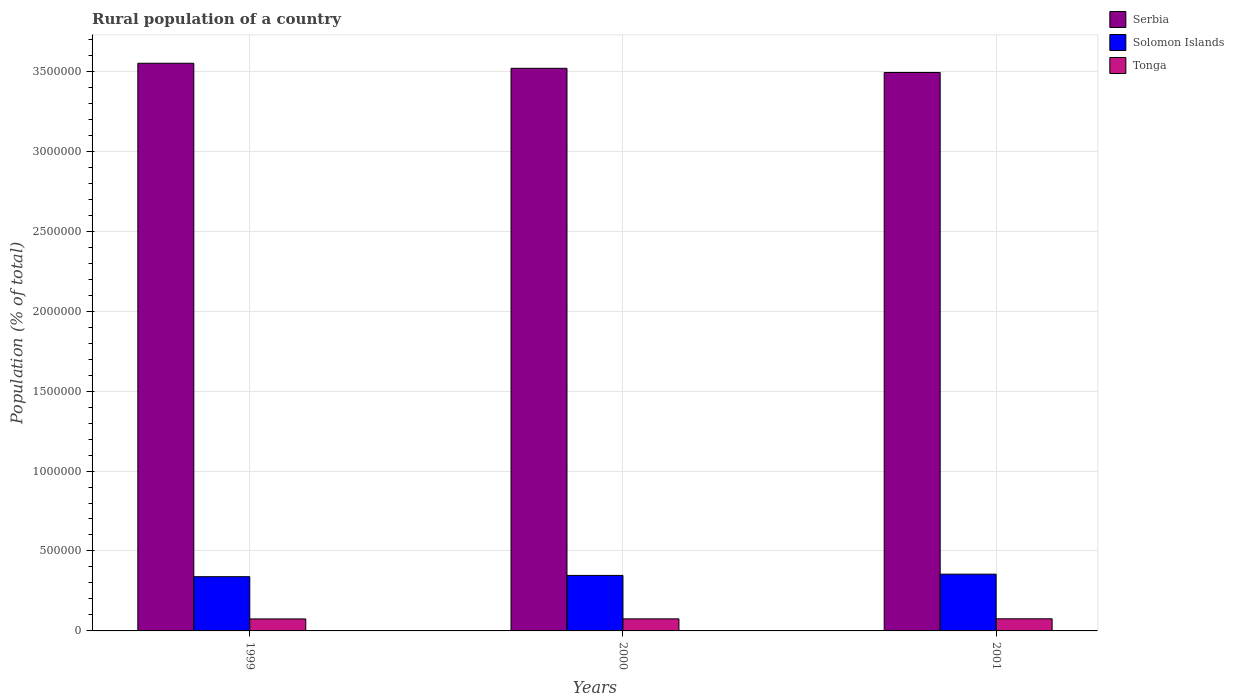How many groups of bars are there?
Your answer should be very brief. 3. Are the number of bars on each tick of the X-axis equal?
Provide a succinct answer. Yes. In how many cases, is the number of bars for a given year not equal to the number of legend labels?
Your response must be concise. 0. What is the rural population in Serbia in 2000?
Provide a succinct answer. 3.52e+06. Across all years, what is the maximum rural population in Serbia?
Your response must be concise. 3.55e+06. Across all years, what is the minimum rural population in Solomon Islands?
Provide a short and direct response. 3.39e+05. In which year was the rural population in Tonga maximum?
Your answer should be compact. 2001. In which year was the rural population in Solomon Islands minimum?
Your response must be concise. 1999. What is the total rural population in Serbia in the graph?
Offer a very short reply. 1.06e+07. What is the difference between the rural population in Serbia in 1999 and that in 2000?
Your answer should be compact. 3.15e+04. What is the difference between the rural population in Serbia in 2001 and the rural population in Solomon Islands in 1999?
Your response must be concise. 3.15e+06. What is the average rural population in Solomon Islands per year?
Your answer should be compact. 3.47e+05. In the year 2000, what is the difference between the rural population in Solomon Islands and rural population in Tonga?
Offer a terse response. 2.72e+05. In how many years, is the rural population in Tonga greater than 2200000 %?
Keep it short and to the point. 0. What is the ratio of the rural population in Serbia in 1999 to that in 2001?
Provide a succinct answer. 1.02. What is the difference between the highest and the second highest rural population in Serbia?
Offer a terse response. 3.15e+04. What is the difference between the highest and the lowest rural population in Serbia?
Your answer should be very brief. 5.77e+04. What does the 1st bar from the left in 2000 represents?
Your answer should be compact. Serbia. What does the 3rd bar from the right in 2001 represents?
Make the answer very short. Serbia. Is it the case that in every year, the sum of the rural population in Solomon Islands and rural population in Tonga is greater than the rural population in Serbia?
Offer a very short reply. No. Are all the bars in the graph horizontal?
Your answer should be compact. No. Does the graph contain any zero values?
Your response must be concise. No. Does the graph contain grids?
Give a very brief answer. Yes. How are the legend labels stacked?
Give a very brief answer. Vertical. What is the title of the graph?
Your answer should be compact. Rural population of a country. What is the label or title of the Y-axis?
Make the answer very short. Population (% of total). What is the Population (% of total) of Serbia in 1999?
Keep it short and to the point. 3.55e+06. What is the Population (% of total) of Solomon Islands in 1999?
Keep it short and to the point. 3.39e+05. What is the Population (% of total) of Tonga in 1999?
Make the answer very short. 7.50e+04. What is the Population (% of total) in Serbia in 2000?
Your response must be concise. 3.52e+06. What is the Population (% of total) in Solomon Islands in 2000?
Your answer should be very brief. 3.47e+05. What is the Population (% of total) in Tonga in 2000?
Your response must be concise. 7.54e+04. What is the Population (% of total) of Serbia in 2001?
Your answer should be compact. 3.49e+06. What is the Population (% of total) in Solomon Islands in 2001?
Ensure brevity in your answer.  3.55e+05. What is the Population (% of total) in Tonga in 2001?
Offer a very short reply. 7.58e+04. Across all years, what is the maximum Population (% of total) of Serbia?
Provide a short and direct response. 3.55e+06. Across all years, what is the maximum Population (% of total) of Solomon Islands?
Ensure brevity in your answer.  3.55e+05. Across all years, what is the maximum Population (% of total) of Tonga?
Make the answer very short. 7.58e+04. Across all years, what is the minimum Population (% of total) of Serbia?
Give a very brief answer. 3.49e+06. Across all years, what is the minimum Population (% of total) of Solomon Islands?
Your answer should be very brief. 3.39e+05. Across all years, what is the minimum Population (% of total) of Tonga?
Provide a succinct answer. 7.50e+04. What is the total Population (% of total) of Serbia in the graph?
Keep it short and to the point. 1.06e+07. What is the total Population (% of total) of Solomon Islands in the graph?
Your answer should be compact. 1.04e+06. What is the total Population (% of total) in Tonga in the graph?
Provide a short and direct response. 2.26e+05. What is the difference between the Population (% of total) in Serbia in 1999 and that in 2000?
Make the answer very short. 3.15e+04. What is the difference between the Population (% of total) in Solomon Islands in 1999 and that in 2000?
Provide a short and direct response. -8002. What is the difference between the Population (% of total) in Tonga in 1999 and that in 2000?
Your response must be concise. -358. What is the difference between the Population (% of total) in Serbia in 1999 and that in 2001?
Make the answer very short. 5.77e+04. What is the difference between the Population (% of total) of Solomon Islands in 1999 and that in 2001?
Provide a succinct answer. -1.58e+04. What is the difference between the Population (% of total) of Tonga in 1999 and that in 2001?
Provide a short and direct response. -742. What is the difference between the Population (% of total) in Serbia in 2000 and that in 2001?
Give a very brief answer. 2.62e+04. What is the difference between the Population (% of total) in Solomon Islands in 2000 and that in 2001?
Give a very brief answer. -7785. What is the difference between the Population (% of total) of Tonga in 2000 and that in 2001?
Give a very brief answer. -384. What is the difference between the Population (% of total) of Serbia in 1999 and the Population (% of total) of Solomon Islands in 2000?
Offer a very short reply. 3.20e+06. What is the difference between the Population (% of total) of Serbia in 1999 and the Population (% of total) of Tonga in 2000?
Provide a succinct answer. 3.47e+06. What is the difference between the Population (% of total) of Solomon Islands in 1999 and the Population (% of total) of Tonga in 2000?
Offer a terse response. 2.64e+05. What is the difference between the Population (% of total) of Serbia in 1999 and the Population (% of total) of Solomon Islands in 2001?
Your answer should be very brief. 3.20e+06. What is the difference between the Population (% of total) in Serbia in 1999 and the Population (% of total) in Tonga in 2001?
Offer a very short reply. 3.47e+06. What is the difference between the Population (% of total) in Solomon Islands in 1999 and the Population (% of total) in Tonga in 2001?
Keep it short and to the point. 2.63e+05. What is the difference between the Population (% of total) in Serbia in 2000 and the Population (% of total) in Solomon Islands in 2001?
Provide a succinct answer. 3.16e+06. What is the difference between the Population (% of total) in Serbia in 2000 and the Population (% of total) in Tonga in 2001?
Provide a short and direct response. 3.44e+06. What is the difference between the Population (% of total) in Solomon Islands in 2000 and the Population (% of total) in Tonga in 2001?
Give a very brief answer. 2.71e+05. What is the average Population (% of total) in Serbia per year?
Your response must be concise. 3.52e+06. What is the average Population (% of total) in Solomon Islands per year?
Offer a very short reply. 3.47e+05. What is the average Population (% of total) of Tonga per year?
Offer a terse response. 7.54e+04. In the year 1999, what is the difference between the Population (% of total) in Serbia and Population (% of total) in Solomon Islands?
Keep it short and to the point. 3.21e+06. In the year 1999, what is the difference between the Population (% of total) of Serbia and Population (% of total) of Tonga?
Make the answer very short. 3.48e+06. In the year 1999, what is the difference between the Population (% of total) in Solomon Islands and Population (% of total) in Tonga?
Give a very brief answer. 2.64e+05. In the year 2000, what is the difference between the Population (% of total) in Serbia and Population (% of total) in Solomon Islands?
Make the answer very short. 3.17e+06. In the year 2000, what is the difference between the Population (% of total) of Serbia and Population (% of total) of Tonga?
Provide a succinct answer. 3.44e+06. In the year 2000, what is the difference between the Population (% of total) of Solomon Islands and Population (% of total) of Tonga?
Ensure brevity in your answer.  2.72e+05. In the year 2001, what is the difference between the Population (% of total) in Serbia and Population (% of total) in Solomon Islands?
Give a very brief answer. 3.14e+06. In the year 2001, what is the difference between the Population (% of total) of Serbia and Population (% of total) of Tonga?
Provide a short and direct response. 3.42e+06. In the year 2001, what is the difference between the Population (% of total) of Solomon Islands and Population (% of total) of Tonga?
Keep it short and to the point. 2.79e+05. What is the ratio of the Population (% of total) of Solomon Islands in 1999 to that in 2000?
Give a very brief answer. 0.98. What is the ratio of the Population (% of total) of Tonga in 1999 to that in 2000?
Your answer should be compact. 1. What is the ratio of the Population (% of total) in Serbia in 1999 to that in 2001?
Give a very brief answer. 1.02. What is the ratio of the Population (% of total) in Solomon Islands in 1999 to that in 2001?
Provide a short and direct response. 0.96. What is the ratio of the Population (% of total) in Tonga in 1999 to that in 2001?
Keep it short and to the point. 0.99. What is the ratio of the Population (% of total) in Serbia in 2000 to that in 2001?
Your answer should be compact. 1.01. What is the ratio of the Population (% of total) in Solomon Islands in 2000 to that in 2001?
Your answer should be compact. 0.98. What is the difference between the highest and the second highest Population (% of total) of Serbia?
Ensure brevity in your answer.  3.15e+04. What is the difference between the highest and the second highest Population (% of total) in Solomon Islands?
Make the answer very short. 7785. What is the difference between the highest and the second highest Population (% of total) in Tonga?
Offer a very short reply. 384. What is the difference between the highest and the lowest Population (% of total) of Serbia?
Keep it short and to the point. 5.77e+04. What is the difference between the highest and the lowest Population (% of total) of Solomon Islands?
Give a very brief answer. 1.58e+04. What is the difference between the highest and the lowest Population (% of total) in Tonga?
Keep it short and to the point. 742. 